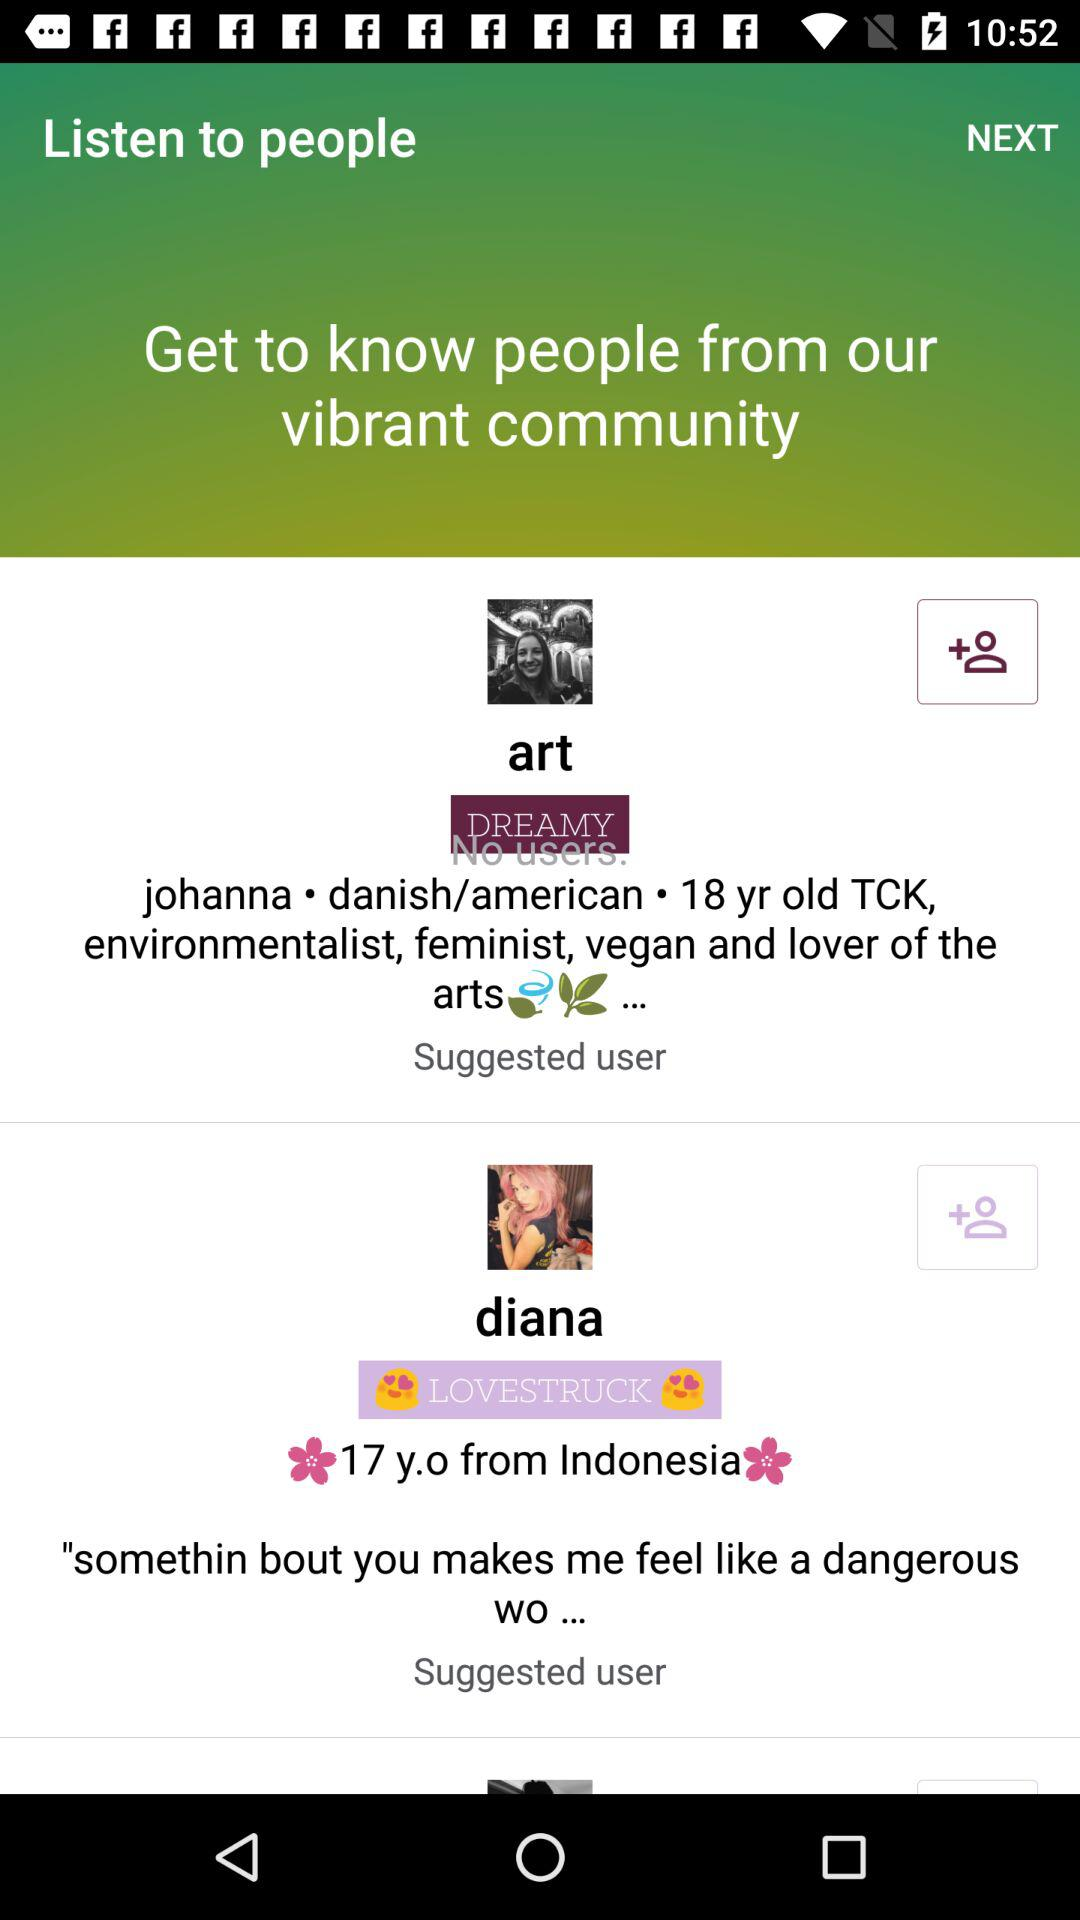How many suggested users are there?
Answer the question using a single word or phrase. 2 